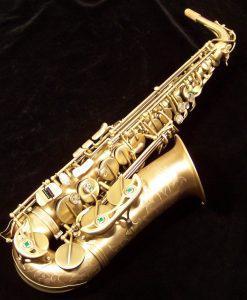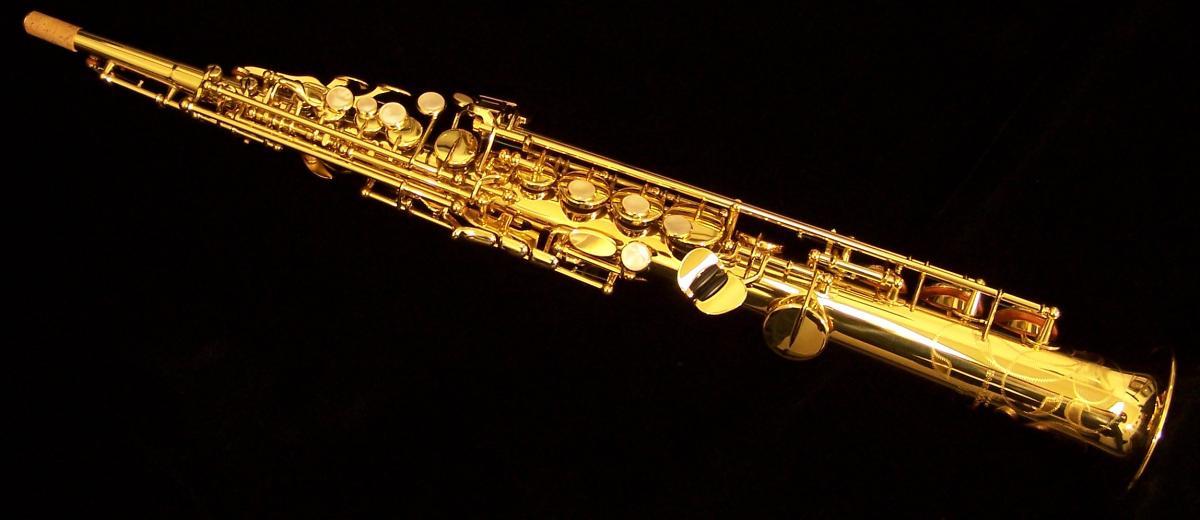The first image is the image on the left, the second image is the image on the right. Assess this claim about the two images: "One image shows a saxophone with a curved bell end that has its mouthpiece separate and lying near the saxophone's bell.". Correct or not? Answer yes or no. No. 